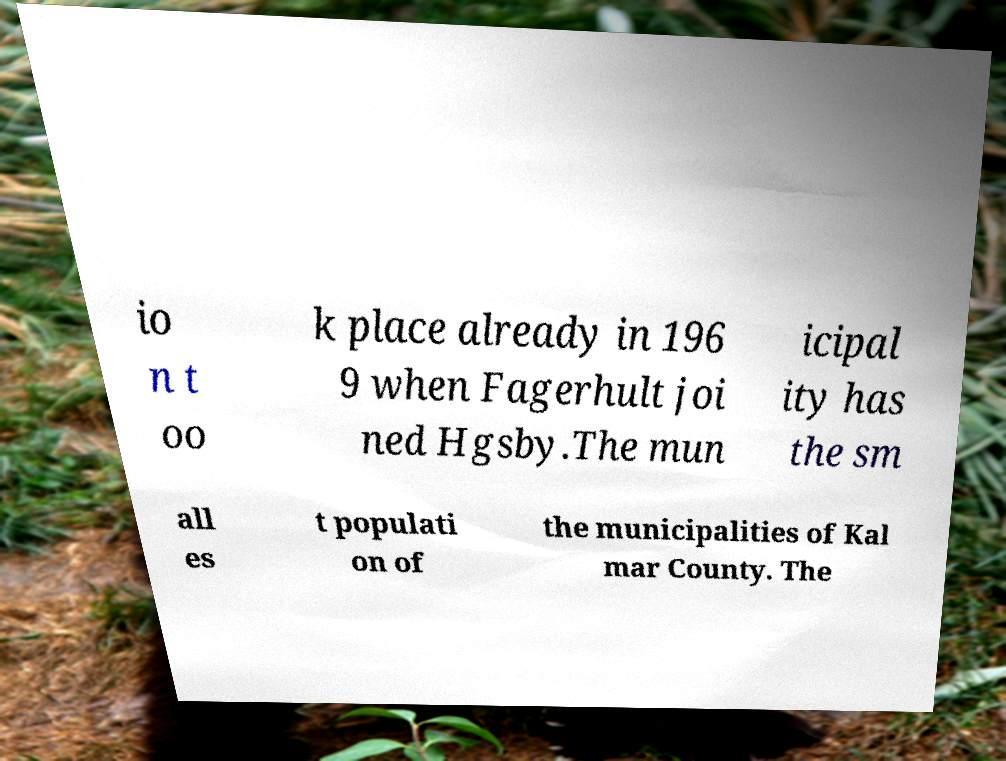I need the written content from this picture converted into text. Can you do that? io n t oo k place already in 196 9 when Fagerhult joi ned Hgsby.The mun icipal ity has the sm all es t populati on of the municipalities of Kal mar County. The 